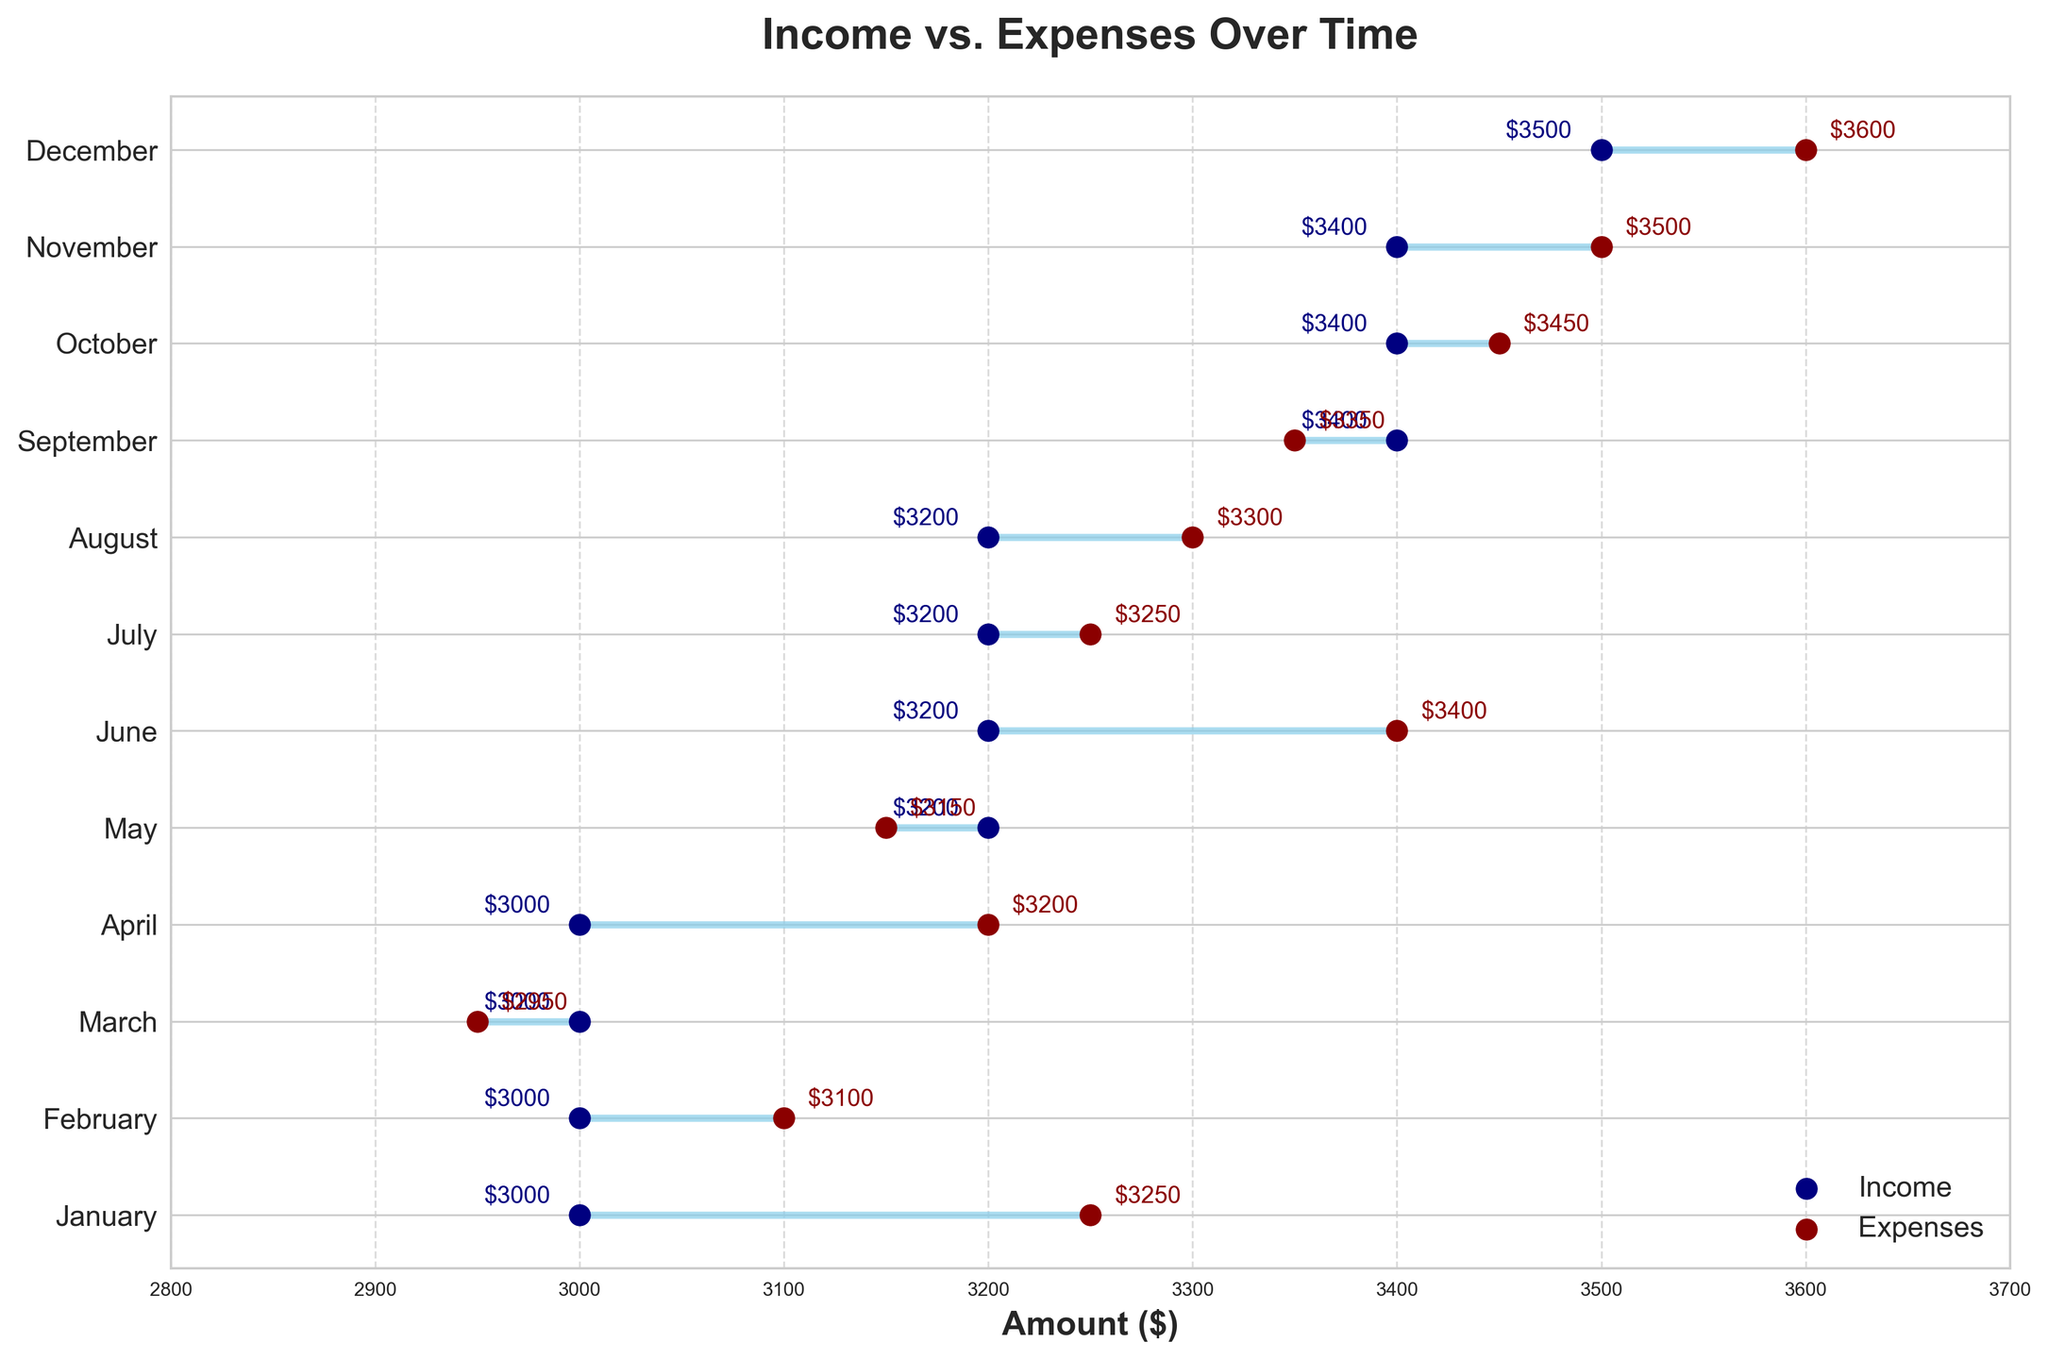What is the title of the plot? The title of the plot is displayed prominently at the top. This is the easiest element to identify on any plot.
Answer: Income vs. Expenses Over Time Which month has the highest income? You can find this by looking at the highest point for the blue dots, which represent income, on the horizontal axis. December has the highest income with a value of $3500.
Answer: December In which months are the income and expenses equal for the same month? To find months where income equals expenses, look for months where the blue and red dots overlap. There isn't any month where both dots overlap; hence, income and expenses are not equal in any month.
Answer: None What is the difference between income and expenses in November? Find the income and expenses for November and subtract the smaller value from the larger one ($3500 - $3400).
Answer: $100 During which month was the expense the highest? Look at the highest red dot on the horizontal axis, which represents expenses. The expenses are highest in December at $3600.
Answer: December How many months are shown in the plot? Each horizontal line corresponds to a month, and you can count the number of lines.
Answer: 12 What is the average income for the first quarter (January, February, March)? Add up the incomes for January, February, and March ($3000 + $3000 + $3000) and divide by 3 to get the average.
Answer: $3000 Which month has the smallest gap between income and expenses? The smallest gap can be determined by examining which horizontal line has the shortest distance between the blue dot (income) and the red dot (expenses). May has the smallest gap of $50 ($3200 - $3150).
Answer: May In which month did the expenses first exceed the income? Look for the first instance where the red dot is to the right of the blue dot along the horizontal axis.
Answer: January For which months did the income values increase compared to the previous month? Compare the income values month-by-month and note when they increase. May, September, and December show an increase in income from the previous months.
Answer: May, September, December 